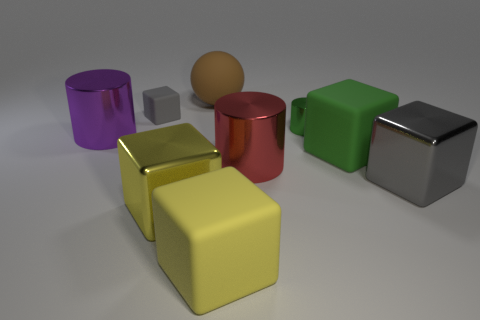There is a gray object that is to the right of the small gray rubber thing; is it the same shape as the small gray rubber object?
Your answer should be compact. Yes. How many gray blocks are both left of the brown matte object and on the right side of the green cylinder?
Offer a terse response. 0. What number of other objects are the same size as the brown thing?
Provide a succinct answer. 6. Are there the same number of brown objects that are right of the yellow matte block and tiny green things?
Offer a very short reply. No. Is the color of the large cylinder that is in front of the large purple metal cylinder the same as the shiny cube on the right side of the tiny cylinder?
Provide a short and direct response. No. The thing that is in front of the tiny green shiny object and behind the green rubber thing is made of what material?
Make the answer very short. Metal. The tiny rubber thing is what color?
Your answer should be very brief. Gray. What number of other things are the same shape as the yellow matte thing?
Make the answer very short. 4. Are there an equal number of yellow blocks behind the matte sphere and big green things right of the gray metal block?
Give a very brief answer. Yes. What is the material of the large gray cube?
Make the answer very short. Metal. 